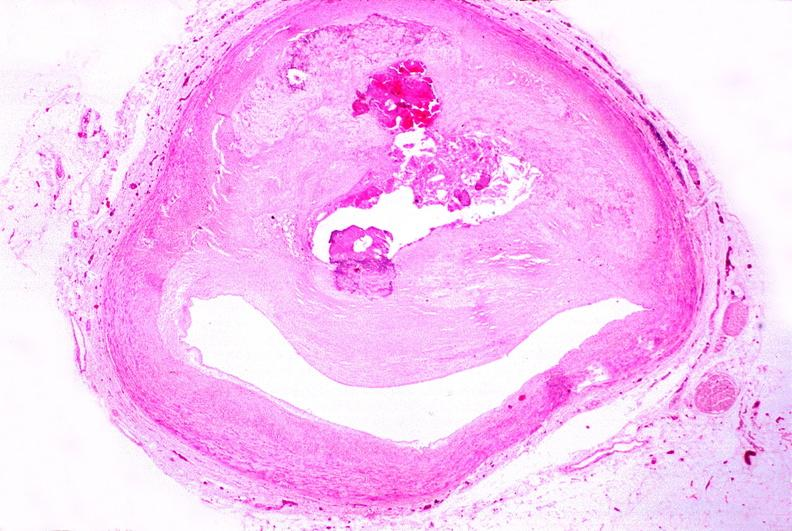where is this in?
Answer the question using a single word or phrase. In vasculature 